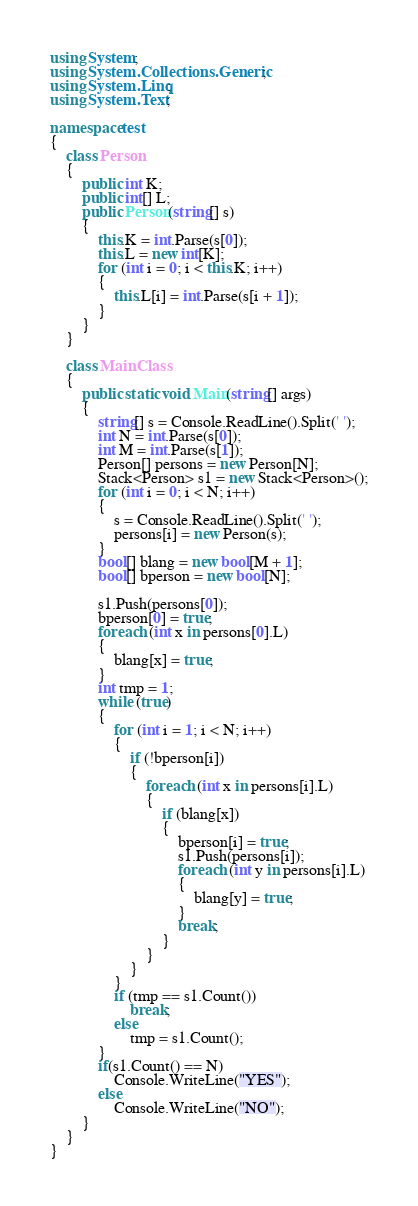Convert code to text. <code><loc_0><loc_0><loc_500><loc_500><_C#_>using System;
using System.Collections.Generic;
using System.Linq;
using System.Text;

namespace test
{
	class Person
	{
		public int K;
		public int[] L;
		public Person(string[] s)
		{
			this.K = int.Parse(s[0]);
			this.L = new int[K];
			for (int i = 0; i < this.K; i++)
			{
				this.L[i] = int.Parse(s[i + 1]);
			}
		}
	}

	class MainClass
	{
		public static void Main(string[] args)
		{
			string[] s = Console.ReadLine().Split(' ');
			int N = int.Parse(s[0]);
			int M = int.Parse(s[1]);
			Person[] persons = new Person[N];
			Stack<Person> s1 = new Stack<Person>();
			for (int i = 0; i < N; i++)
			{
				s = Console.ReadLine().Split(' ');
				persons[i] = new Person(s);
			}
			bool[] blang = new bool[M + 1];
			bool[] bperson = new bool[N];

			s1.Push(persons[0]);
			bperson[0] = true;
			foreach (int x in persons[0].L)
			{
				blang[x] = true;
			}
			int tmp = 1;
			while (true)
			{
				for (int i = 1; i < N; i++)
				{
					if (!bperson[i])
					{
						foreach (int x in persons[i].L)
						{
							if (blang[x])
							{
								bperson[i] = true;
								s1.Push(persons[i]);
								foreach (int y in persons[i].L)
								{
									blang[y] = true;
								}
								break;
							}
						}
					}
				}
				if (tmp == s1.Count())
					break;
				else
					tmp = s1.Count();
			}
			if(s1.Count() == N)
				Console.WriteLine("YES");
			else
				Console.WriteLine("NO");
		}
	}
}
</code> 